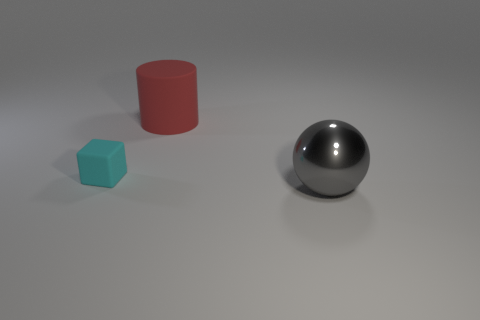Add 2 large gray rubber objects. How many objects exist? 5 Subtract all balls. How many objects are left? 2 Subtract all brown cylinders. Subtract all gray balls. How many cylinders are left? 1 Subtract all tiny purple matte balls. Subtract all large rubber objects. How many objects are left? 2 Add 2 cyan rubber cubes. How many cyan rubber cubes are left? 3 Add 2 tiny green objects. How many tiny green objects exist? 2 Subtract 0 green cylinders. How many objects are left? 3 